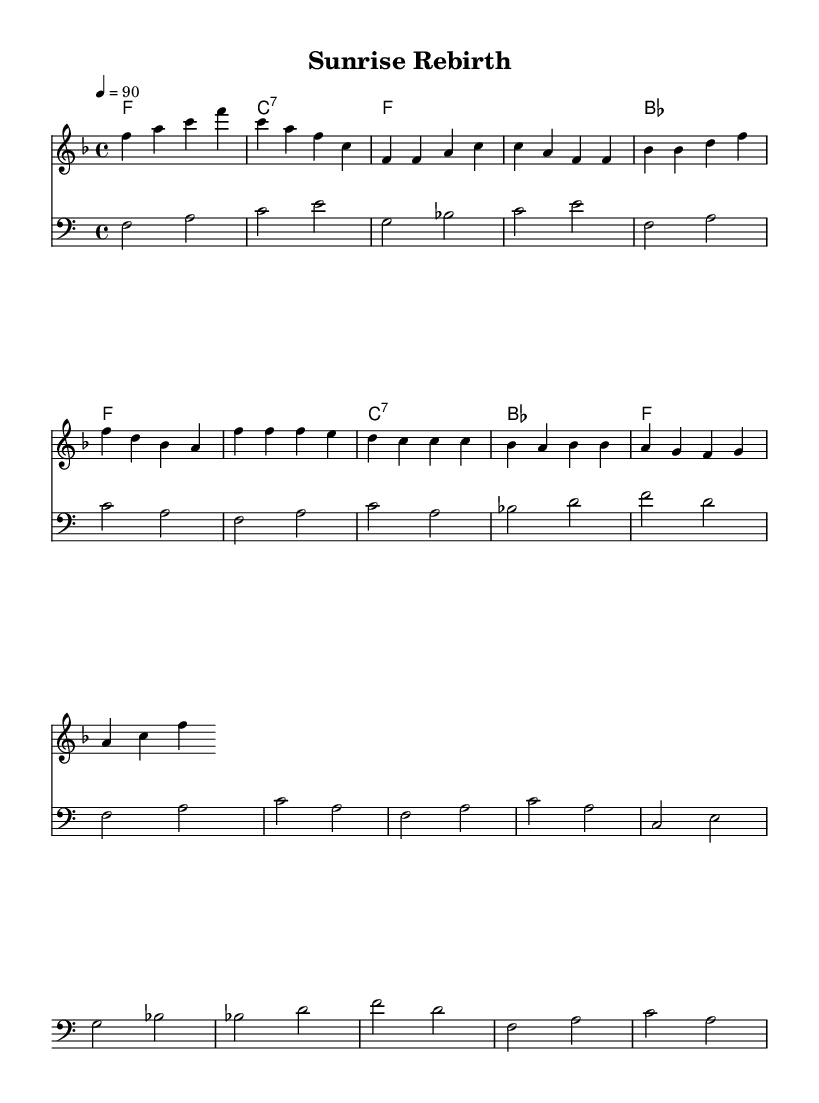What is the key signature of this music? The key signature is F major, which has one flat (B flat). This is identifiable at the beginning of the staff where the key signature is notated.
Answer: F major What is the time signature of this music? The time signature is 4/4, indicating that there are four beats in each measure and the quarter note gets one beat. This is displayed at the start of the score after the key signature.
Answer: 4/4 What is the tempo marking for this piece? The tempo marking is 90 beats per minute, indicated by the "4 = 90" notation at the beginning of the score. This specifies how fast the music should be played.
Answer: 90 How many measures are in the verse section? The verse section, as seen in the melody line, consists of 4 measures, clearly marked with the musical notation. Counting the measures reveals this total.
Answer: 4 What is the primary theme of the lyrics? The lyrics focus on themes of hope and gratitude, expressed in lines about overcoming darkness and celebrating a new day. This can be inferred from both the verse and chorus lyrics provided.
Answer: Hope and gratitude Which chord is played in the chorus section? The primary chord associated with the chorus section is F major, which can be identified through the chord symbols listed above the melody in that part of the score.
Answer: F 